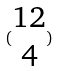<formula> <loc_0><loc_0><loc_500><loc_500>( \begin{matrix} 1 2 \\ 4 \end{matrix} )</formula> 